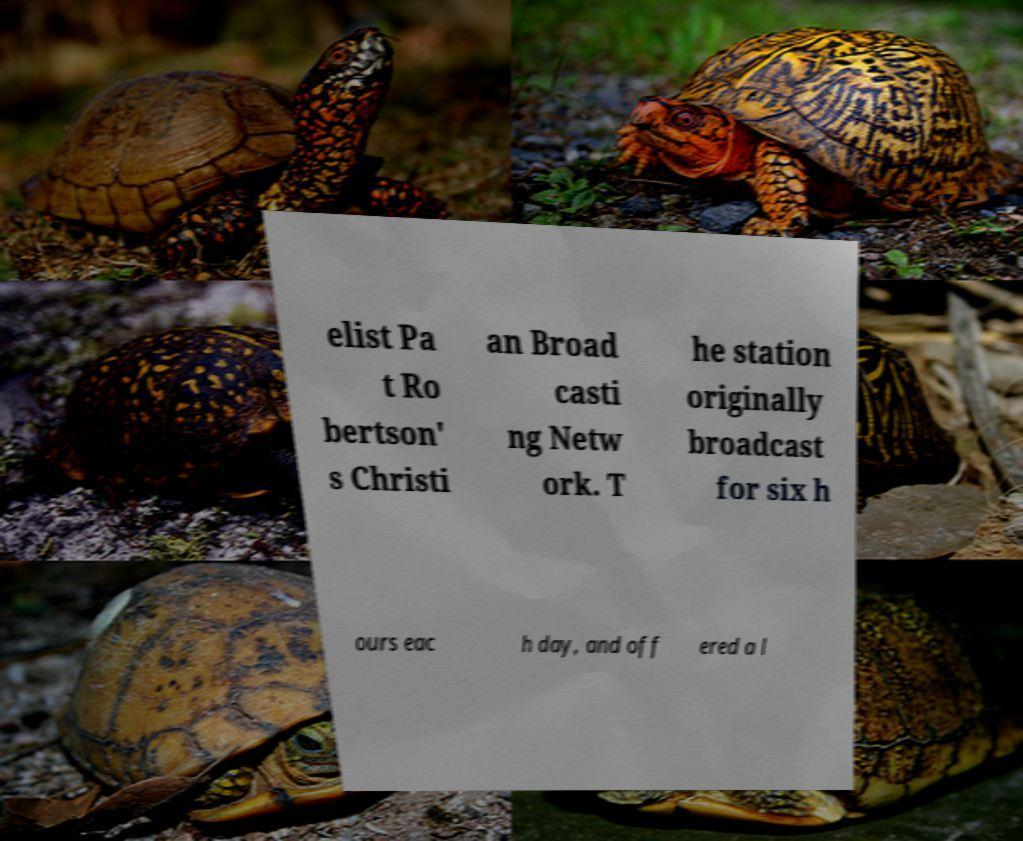Could you assist in decoding the text presented in this image and type it out clearly? elist Pa t Ro bertson' s Christi an Broad casti ng Netw ork. T he station originally broadcast for six h ours eac h day, and off ered a l 